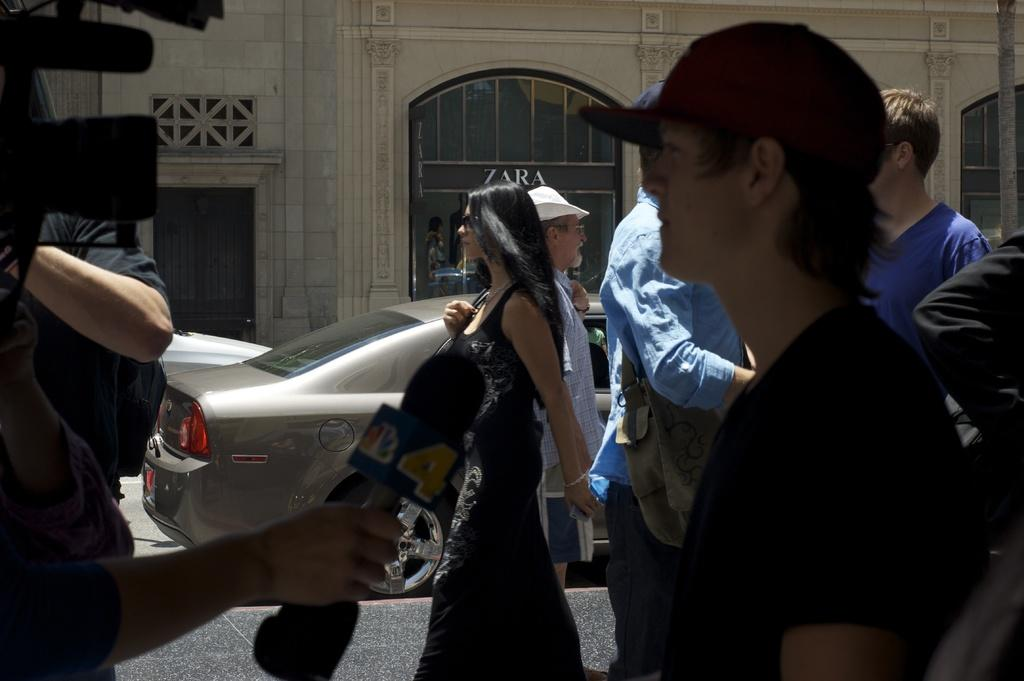What are the people in the image doing? The people in the image are walking on the road at the bottom of the image. What else can be seen in the background of the image? There are two cars in the background of the image. What structure is visible at the top of the image? There is a building visible at the top of the image. What type of oven can be seen in the image? There is no oven present in the image. What direction are the people walking in the image? The image does not provide information about the direction the people are walking. 